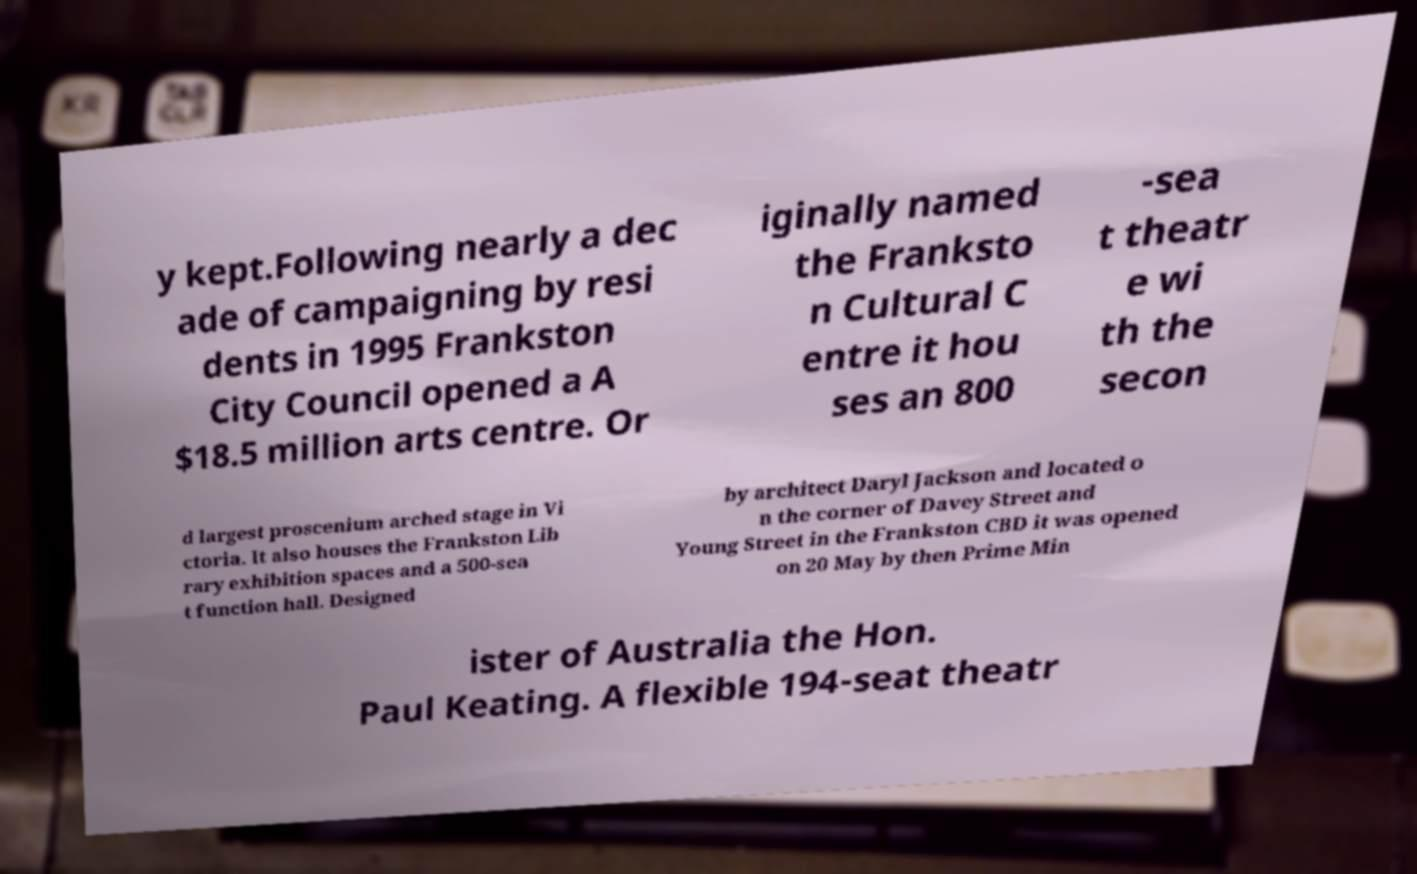There's text embedded in this image that I need extracted. Can you transcribe it verbatim? y kept.Following nearly a dec ade of campaigning by resi dents in 1995 Frankston City Council opened a A $18.5 million arts centre. Or iginally named the Franksto n Cultural C entre it hou ses an 800 -sea t theatr e wi th the secon d largest proscenium arched stage in Vi ctoria. It also houses the Frankston Lib rary exhibition spaces and a 500-sea t function hall. Designed by architect Daryl Jackson and located o n the corner of Davey Street and Young Street in the Frankston CBD it was opened on 20 May by then Prime Min ister of Australia the Hon. Paul Keating. A flexible 194-seat theatr 